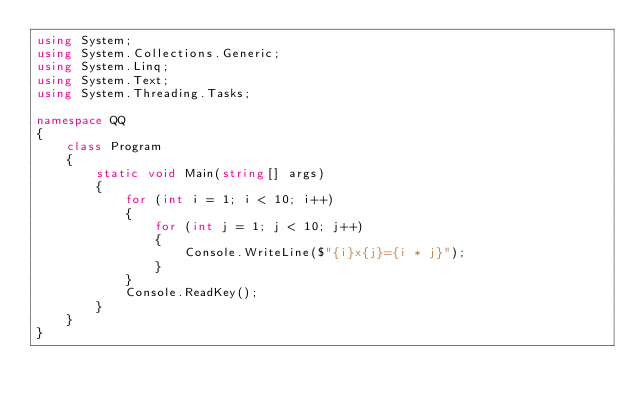<code> <loc_0><loc_0><loc_500><loc_500><_C#_>using System;
using System.Collections.Generic;
using System.Linq;
using System.Text;
using System.Threading.Tasks;

namespace QQ
{
    class Program
    {
        static void Main(string[] args)
        {
            for (int i = 1; i < 10; i++)
            {
                for (int j = 1; j < 10; j++)
                {
                    Console.WriteLine($"{i}x{j}={i * j}");
                }
            }
            Console.ReadKey();
        }
    }
}</code> 